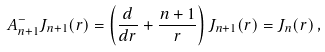Convert formula to latex. <formula><loc_0><loc_0><loc_500><loc_500>A ^ { - } _ { n + 1 } J _ { n + 1 } ( r ) = \left ( \frac { d } { d r } + \frac { n + 1 } { r } \right ) J _ { n + 1 } ( r ) = J _ { n } ( r ) \, ,</formula> 